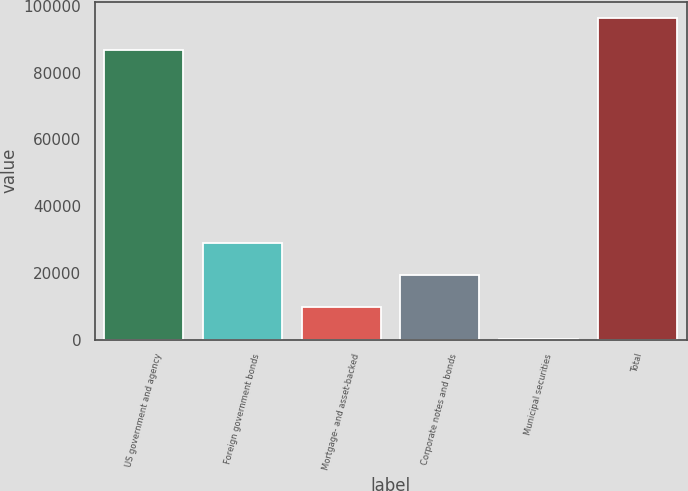Convert chart to OTSL. <chart><loc_0><loc_0><loc_500><loc_500><bar_chart><fcel>US government and agency<fcel>Foreign government bonds<fcel>Mortgage- and asset-backed<fcel>Corporate notes and bonds<fcel>Municipal securities<fcel>Total<nl><fcel>86811<fcel>28803.3<fcel>9631.1<fcel>19217.2<fcel>45<fcel>96397.1<nl></chart> 